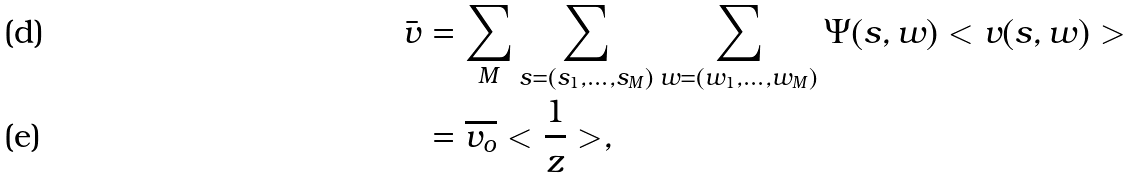Convert formula to latex. <formula><loc_0><loc_0><loc_500><loc_500>\bar { v } & = \sum _ { M } \sum _ { s = ( s _ { 1 } , \dots , s _ { M } ) } \sum _ { w = ( w _ { 1 } , \dots , w _ { M } ) } \Psi ( s , w ) < v ( s , w ) > \\ & = \overline { v _ { o } } < \frac { 1 } { z } > ,</formula> 